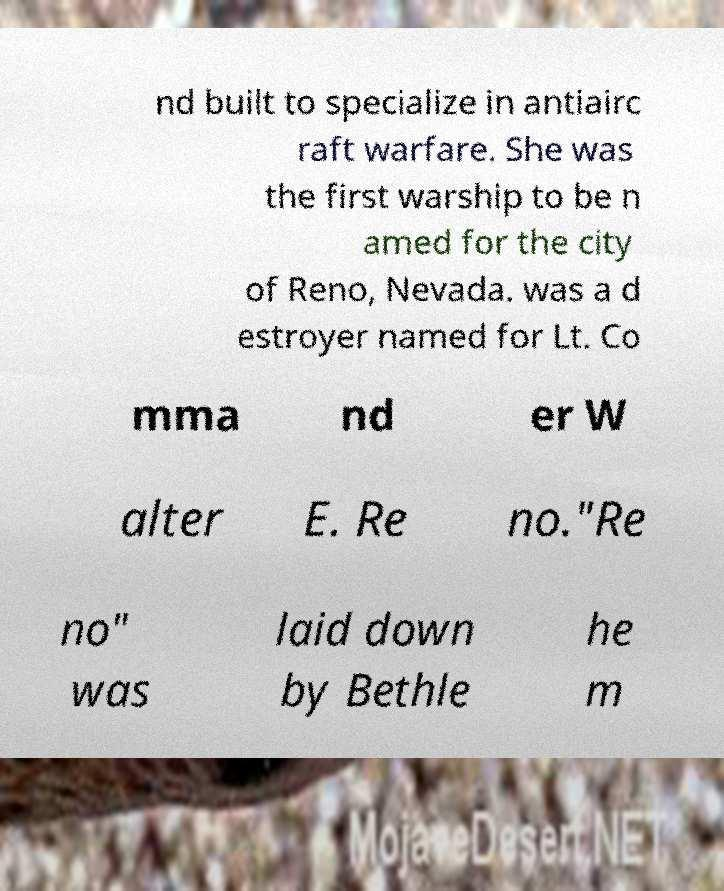Please identify and transcribe the text found in this image. nd built to specialize in antiairc raft warfare. She was the first warship to be n amed for the city of Reno, Nevada. was a d estroyer named for Lt. Co mma nd er W alter E. Re no."Re no" was laid down by Bethle he m 